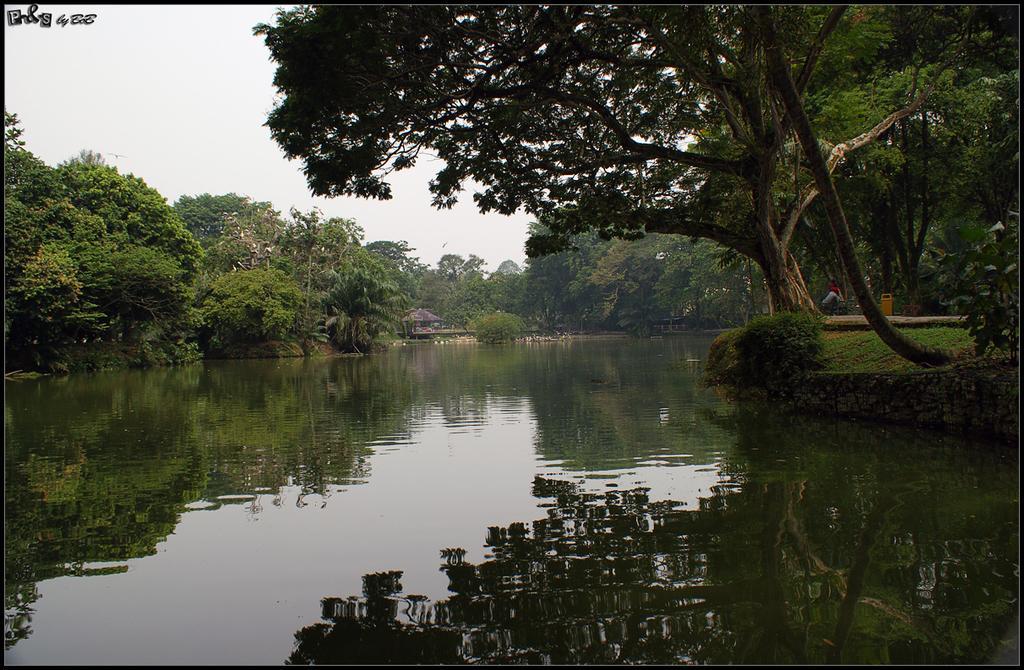Could you give a brief overview of what you see in this image? In this image we can see water. On the sides there are trees. In the background there is sky. In the back there is a shed. In the left top corner something is written. 